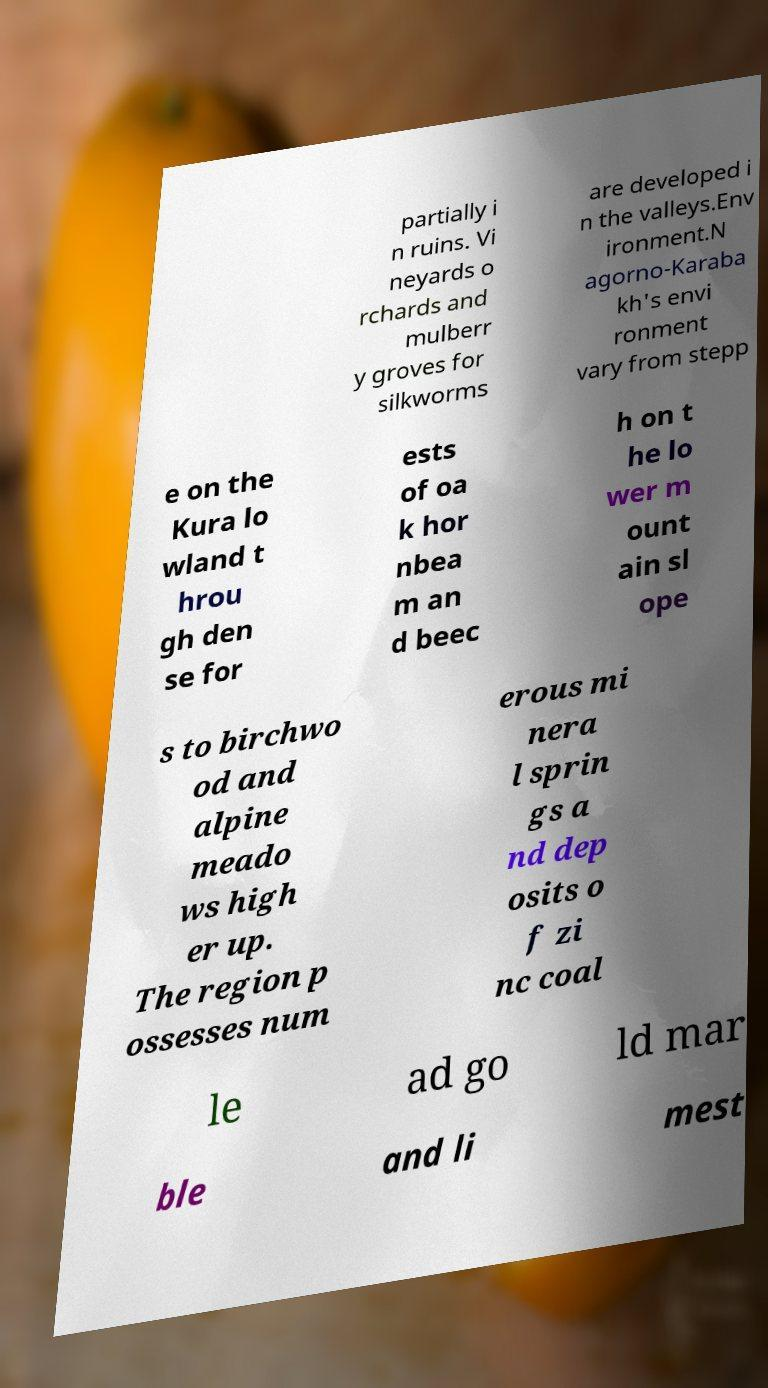Please identify and transcribe the text found in this image. partially i n ruins. Vi neyards o rchards and mulberr y groves for silkworms are developed i n the valleys.Env ironment.N agorno-Karaba kh's envi ronment vary from stepp e on the Kura lo wland t hrou gh den se for ests of oa k hor nbea m an d beec h on t he lo wer m ount ain sl ope s to birchwo od and alpine meado ws high er up. The region p ossesses num erous mi nera l sprin gs a nd dep osits o f zi nc coal le ad go ld mar ble and li mest 